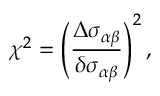<formula> <loc_0><loc_0><loc_500><loc_500>\chi ^ { 2 } = \left ( \frac { \Delta \sigma _ { \alpha \beta } } { \delta \sigma _ { \alpha \beta } } \right ) ^ { 2 } ,</formula> 